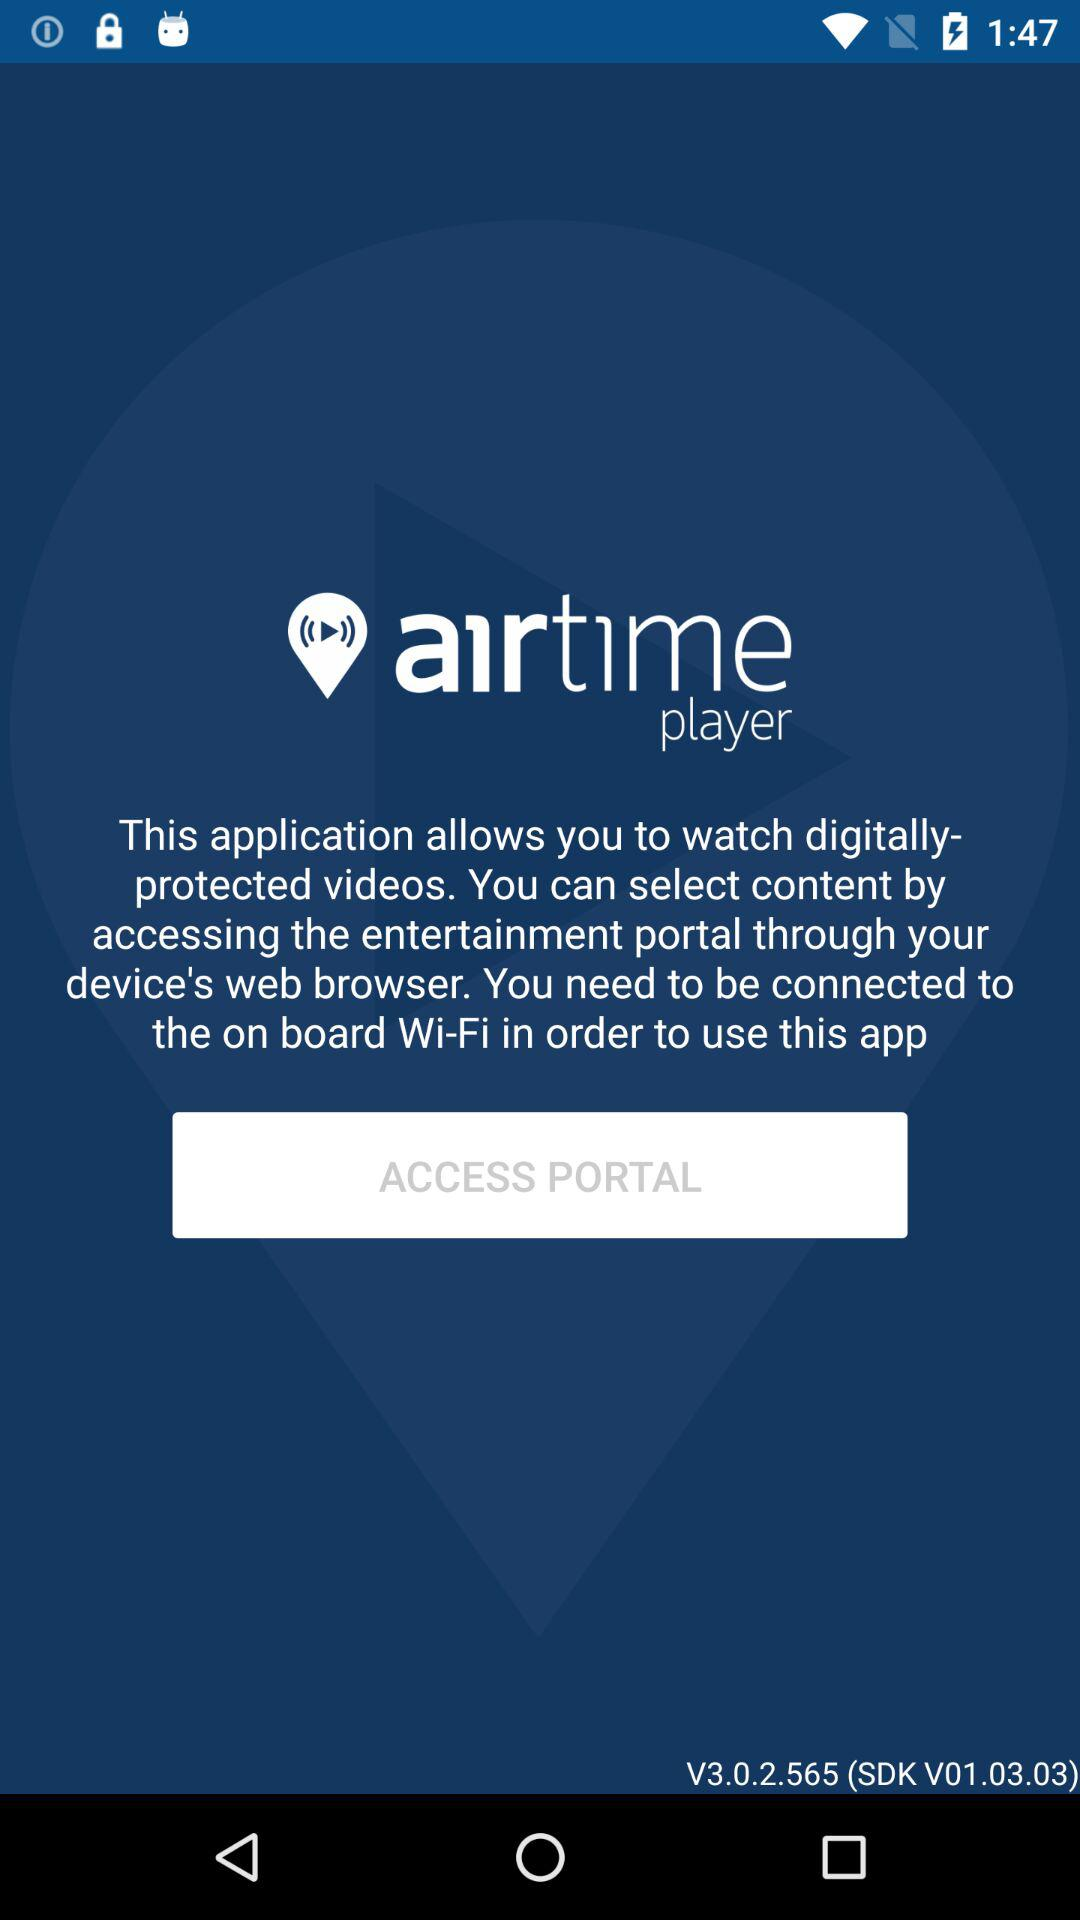What is the name of the application? The name of the application is "airtime player". 